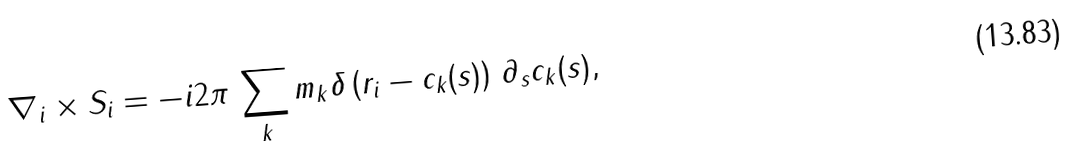Convert formula to latex. <formula><loc_0><loc_0><loc_500><loc_500>\nabla _ { i } \times { S } _ { i } = - i 2 \pi \, \sum _ { k } m _ { k } \delta \left ( { r } _ { i } - { c } _ { k } ( s ) \right ) \, \partial _ { s } { c } _ { k } ( s ) ,</formula> 